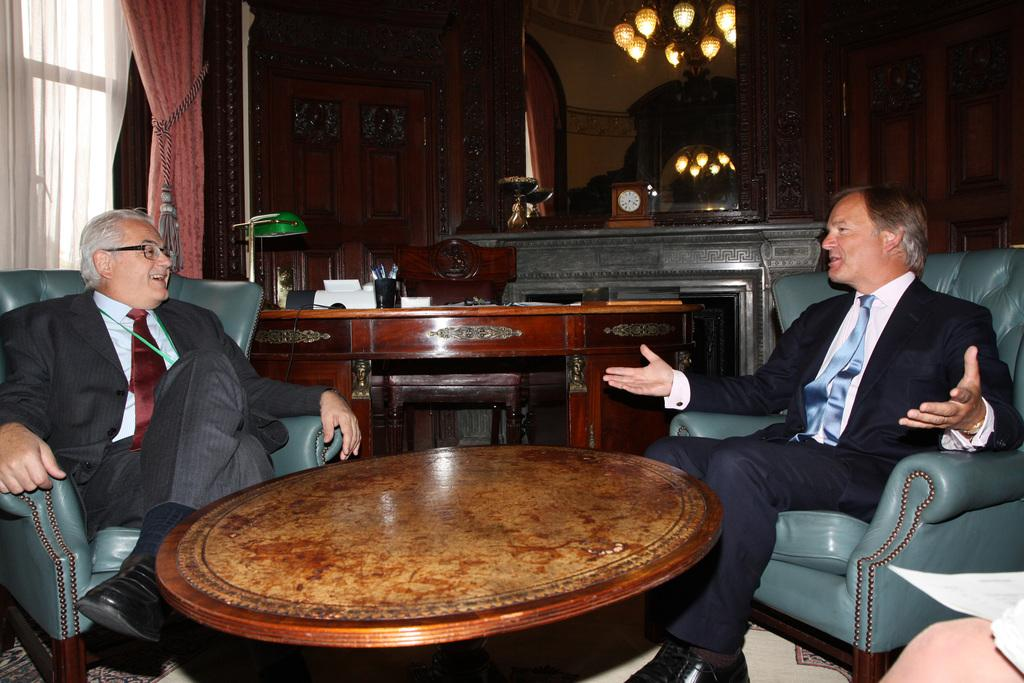How many men are in the image? There are two men in the image. What are the men wearing? The men are wearing suits. What are the men doing in the image? The men are sitting on chairs. Where are the chairs located? The chairs are in front of a table. What can be seen in the background of the image? There is a clock, curtains, and a table with objects in the background of the image. What type of toothbrush is the man using in the image? There is no toothbrush present in the image. How many letters are the men writing in the image? There is no indication that the men are writing letters in the image. 